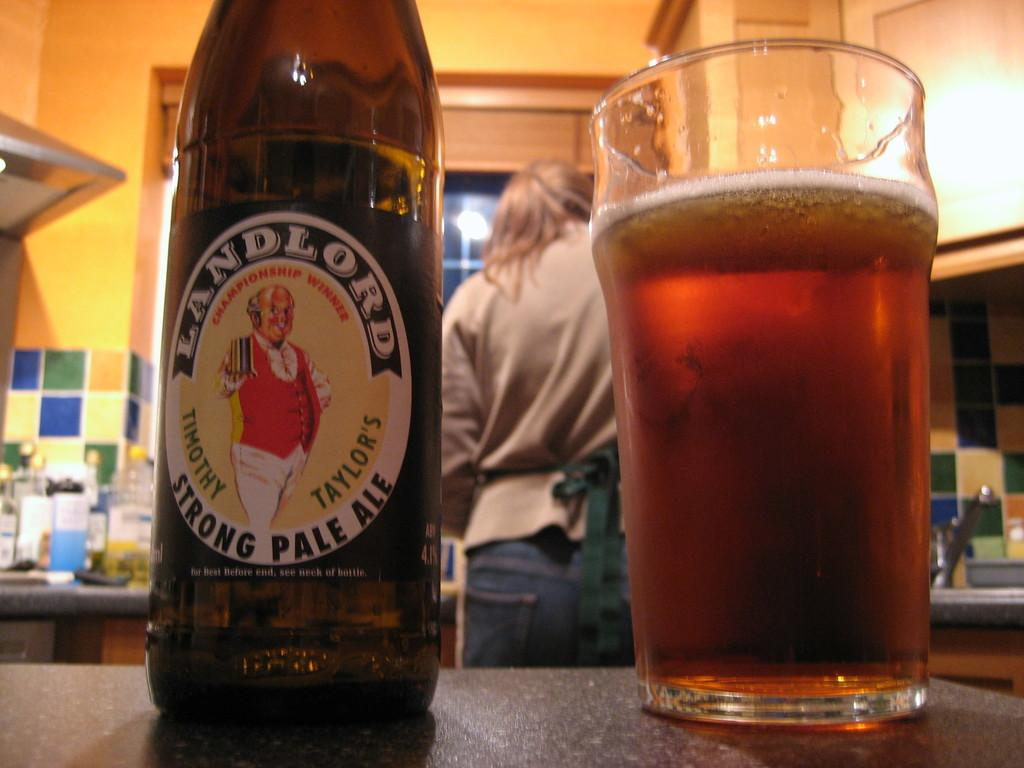<image>
Render a clear and concise summary of the photo. A bottle of Landlord Strong Pale Ale is placed next to a glass half full of beer. 